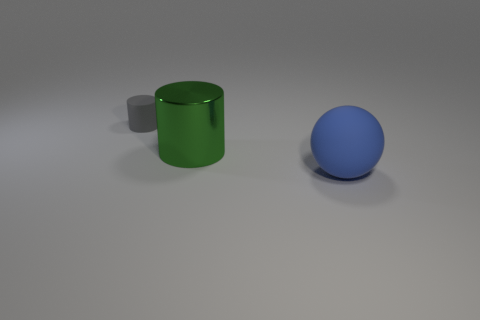Subtract all cylinders. How many objects are left? 1 Subtract 1 spheres. How many spheres are left? 0 Subtract all green spheres. Subtract all purple cubes. How many spheres are left? 1 Subtract all brown blocks. How many cyan spheres are left? 0 Subtract all small yellow matte cylinders. Subtract all large green things. How many objects are left? 2 Add 1 tiny rubber objects. How many tiny rubber objects are left? 2 Add 1 large gray matte cylinders. How many large gray matte cylinders exist? 1 Add 1 red cubes. How many objects exist? 4 Subtract 1 gray cylinders. How many objects are left? 2 